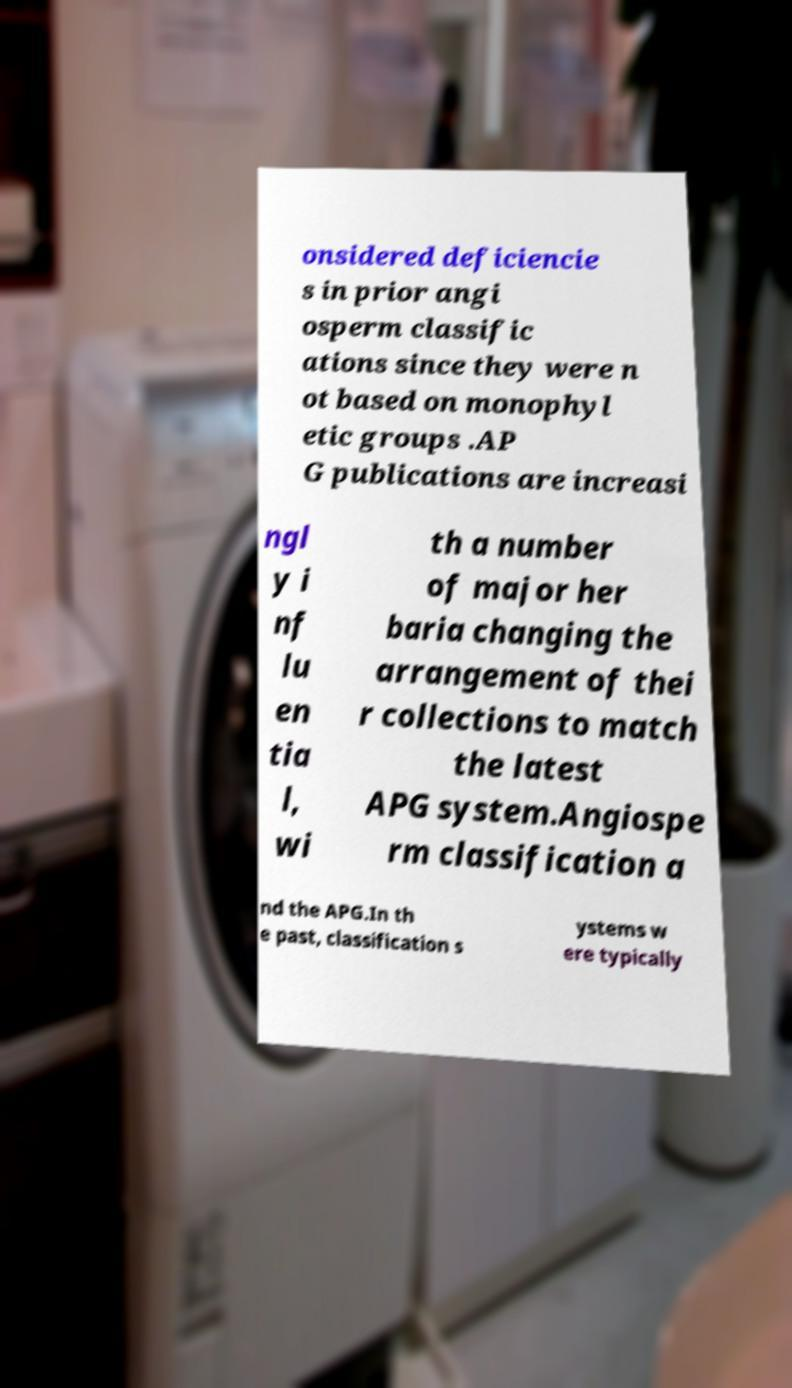I need the written content from this picture converted into text. Can you do that? onsidered deficiencie s in prior angi osperm classific ations since they were n ot based on monophyl etic groups .AP G publications are increasi ngl y i nf lu en tia l, wi th a number of major her baria changing the arrangement of thei r collections to match the latest APG system.Angiospe rm classification a nd the APG.In th e past, classification s ystems w ere typically 